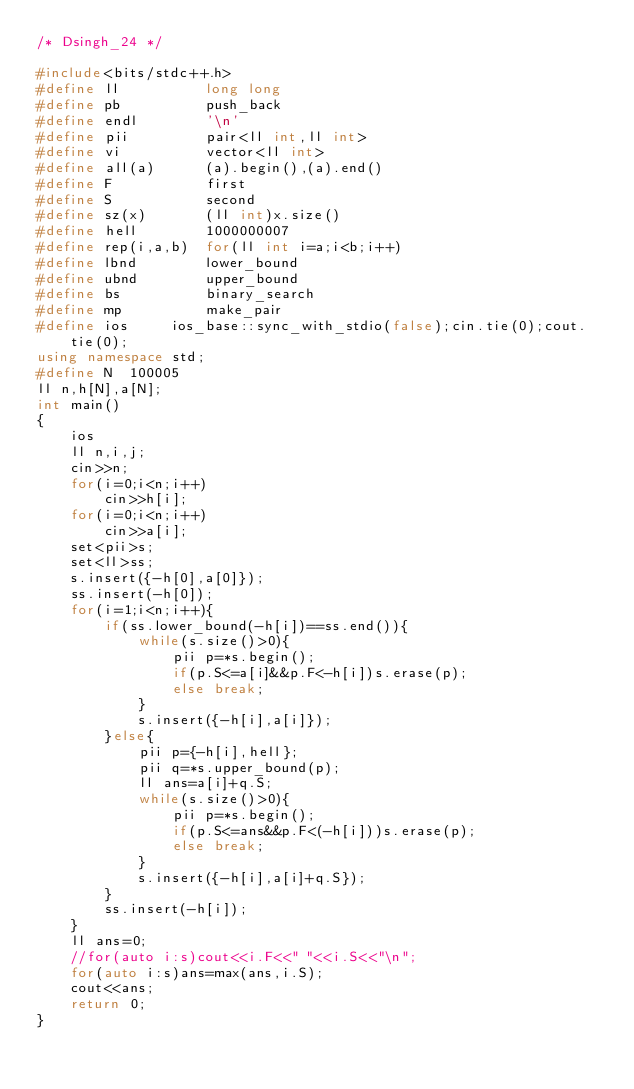Convert code to text. <code><loc_0><loc_0><loc_500><loc_500><_C++_>/* Dsingh_24 */

#include<bits/stdc++.h>
#define ll          long long
#define pb          push_back
#define	endl		'\n'
#define pii         pair<ll int,ll int>
#define vi          vector<ll int>
#define all(a)      (a).begin(),(a).end()
#define F           first
#define S           second
#define sz(x)       (ll int)x.size()
#define hell        1000000007
#define rep(i,a,b)	for(ll int i=a;i<b;i++)
#define lbnd        lower_bound
#define ubnd        upper_bound
#define bs          binary_search
#define mp          make_pair
#define ios	    ios_base::sync_with_stdio(false);cin.tie(0);cout.tie(0);
using namespace std;
#define N  100005
ll n,h[N],a[N];
int main()
{
	ios
	ll n,i,j;
	cin>>n;
	for(i=0;i<n;i++)
		cin>>h[i];
	for(i=0;i<n;i++)
		cin>>a[i];
	set<pii>s;
	set<ll>ss;
	s.insert({-h[0],a[0]});
	ss.insert(-h[0]);
	for(i=1;i<n;i++){
		if(ss.lower_bound(-h[i])==ss.end()){
			while(s.size()>0){
				pii p=*s.begin();
				if(p.S<=a[i]&&p.F<-h[i])s.erase(p);
				else break;
			}
			s.insert({-h[i],a[i]});
		}else{
			pii p={-h[i],hell};
			pii q=*s.upper_bound(p);
			ll ans=a[i]+q.S;
			while(s.size()>0){
				pii p=*s.begin();
				if(p.S<=ans&&p.F<(-h[i]))s.erase(p);
				else break;
			}
			s.insert({-h[i],a[i]+q.S});
		}
		ss.insert(-h[i]);
	}
	ll ans=0;
	//for(auto i:s)cout<<i.F<<" "<<i.S<<"\n";
	for(auto i:s)ans=max(ans,i.S);
	cout<<ans;
	return 0;
}</code> 